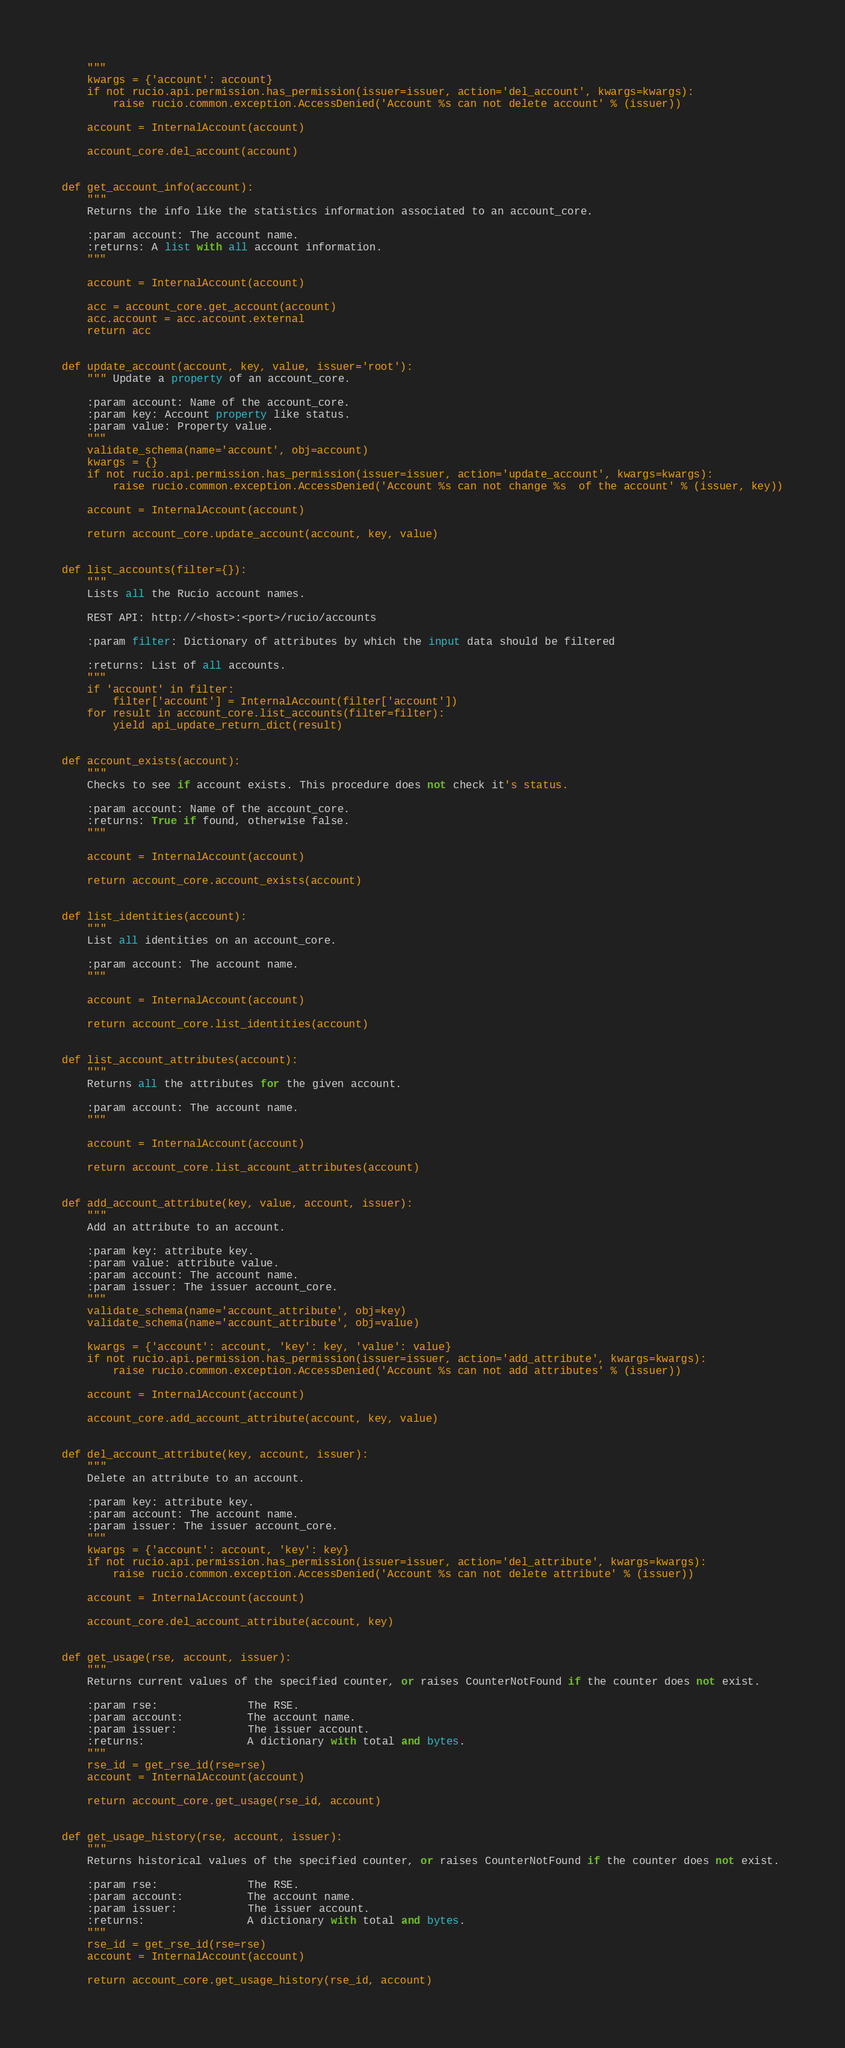Convert code to text. <code><loc_0><loc_0><loc_500><loc_500><_Python_>    """
    kwargs = {'account': account}
    if not rucio.api.permission.has_permission(issuer=issuer, action='del_account', kwargs=kwargs):
        raise rucio.common.exception.AccessDenied('Account %s can not delete account' % (issuer))

    account = InternalAccount(account)

    account_core.del_account(account)


def get_account_info(account):
    """
    Returns the info like the statistics information associated to an account_core.

    :param account: The account name.
    :returns: A list with all account information.
    """

    account = InternalAccount(account)

    acc = account_core.get_account(account)
    acc.account = acc.account.external
    return acc


def update_account(account, key, value, issuer='root'):
    """ Update a property of an account_core.

    :param account: Name of the account_core.
    :param key: Account property like status.
    :param value: Property value.
    """
    validate_schema(name='account', obj=account)
    kwargs = {}
    if not rucio.api.permission.has_permission(issuer=issuer, action='update_account', kwargs=kwargs):
        raise rucio.common.exception.AccessDenied('Account %s can not change %s  of the account' % (issuer, key))

    account = InternalAccount(account)

    return account_core.update_account(account, key, value)


def list_accounts(filter={}):
    """
    Lists all the Rucio account names.

    REST API: http://<host>:<port>/rucio/accounts

    :param filter: Dictionary of attributes by which the input data should be filtered

    :returns: List of all accounts.
    """
    if 'account' in filter:
        filter['account'] = InternalAccount(filter['account'])
    for result in account_core.list_accounts(filter=filter):
        yield api_update_return_dict(result)


def account_exists(account):
    """
    Checks to see if account exists. This procedure does not check it's status.

    :param account: Name of the account_core.
    :returns: True if found, otherwise false.
    """

    account = InternalAccount(account)

    return account_core.account_exists(account)


def list_identities(account):
    """
    List all identities on an account_core.

    :param account: The account name.
    """

    account = InternalAccount(account)

    return account_core.list_identities(account)


def list_account_attributes(account):
    """
    Returns all the attributes for the given account.

    :param account: The account name.
    """

    account = InternalAccount(account)

    return account_core.list_account_attributes(account)


def add_account_attribute(key, value, account, issuer):
    """
    Add an attribute to an account.

    :param key: attribute key.
    :param value: attribute value.
    :param account: The account name.
    :param issuer: The issuer account_core.
    """
    validate_schema(name='account_attribute', obj=key)
    validate_schema(name='account_attribute', obj=value)

    kwargs = {'account': account, 'key': key, 'value': value}
    if not rucio.api.permission.has_permission(issuer=issuer, action='add_attribute', kwargs=kwargs):
        raise rucio.common.exception.AccessDenied('Account %s can not add attributes' % (issuer))

    account = InternalAccount(account)

    account_core.add_account_attribute(account, key, value)


def del_account_attribute(key, account, issuer):
    """
    Delete an attribute to an account.

    :param key: attribute key.
    :param account: The account name.
    :param issuer: The issuer account_core.
    """
    kwargs = {'account': account, 'key': key}
    if not rucio.api.permission.has_permission(issuer=issuer, action='del_attribute', kwargs=kwargs):
        raise rucio.common.exception.AccessDenied('Account %s can not delete attribute' % (issuer))

    account = InternalAccount(account)

    account_core.del_account_attribute(account, key)


def get_usage(rse, account, issuer):
    """
    Returns current values of the specified counter, or raises CounterNotFound if the counter does not exist.

    :param rse:              The RSE.
    :param account:          The account name.
    :param issuer:           The issuer account.
    :returns:                A dictionary with total and bytes.
    """
    rse_id = get_rse_id(rse=rse)
    account = InternalAccount(account)

    return account_core.get_usage(rse_id, account)


def get_usage_history(rse, account, issuer):
    """
    Returns historical values of the specified counter, or raises CounterNotFound if the counter does not exist.

    :param rse:              The RSE.
    :param account:          The account name.
    :param issuer:           The issuer account.
    :returns:                A dictionary with total and bytes.
    """
    rse_id = get_rse_id(rse=rse)
    account = InternalAccount(account)

    return account_core.get_usage_history(rse_id, account)
</code> 